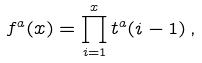<formula> <loc_0><loc_0><loc_500><loc_500>f ^ { a } ( x ) = \prod _ { i = 1 } ^ { x } t ^ { a } ( i - 1 ) \, ,</formula> 